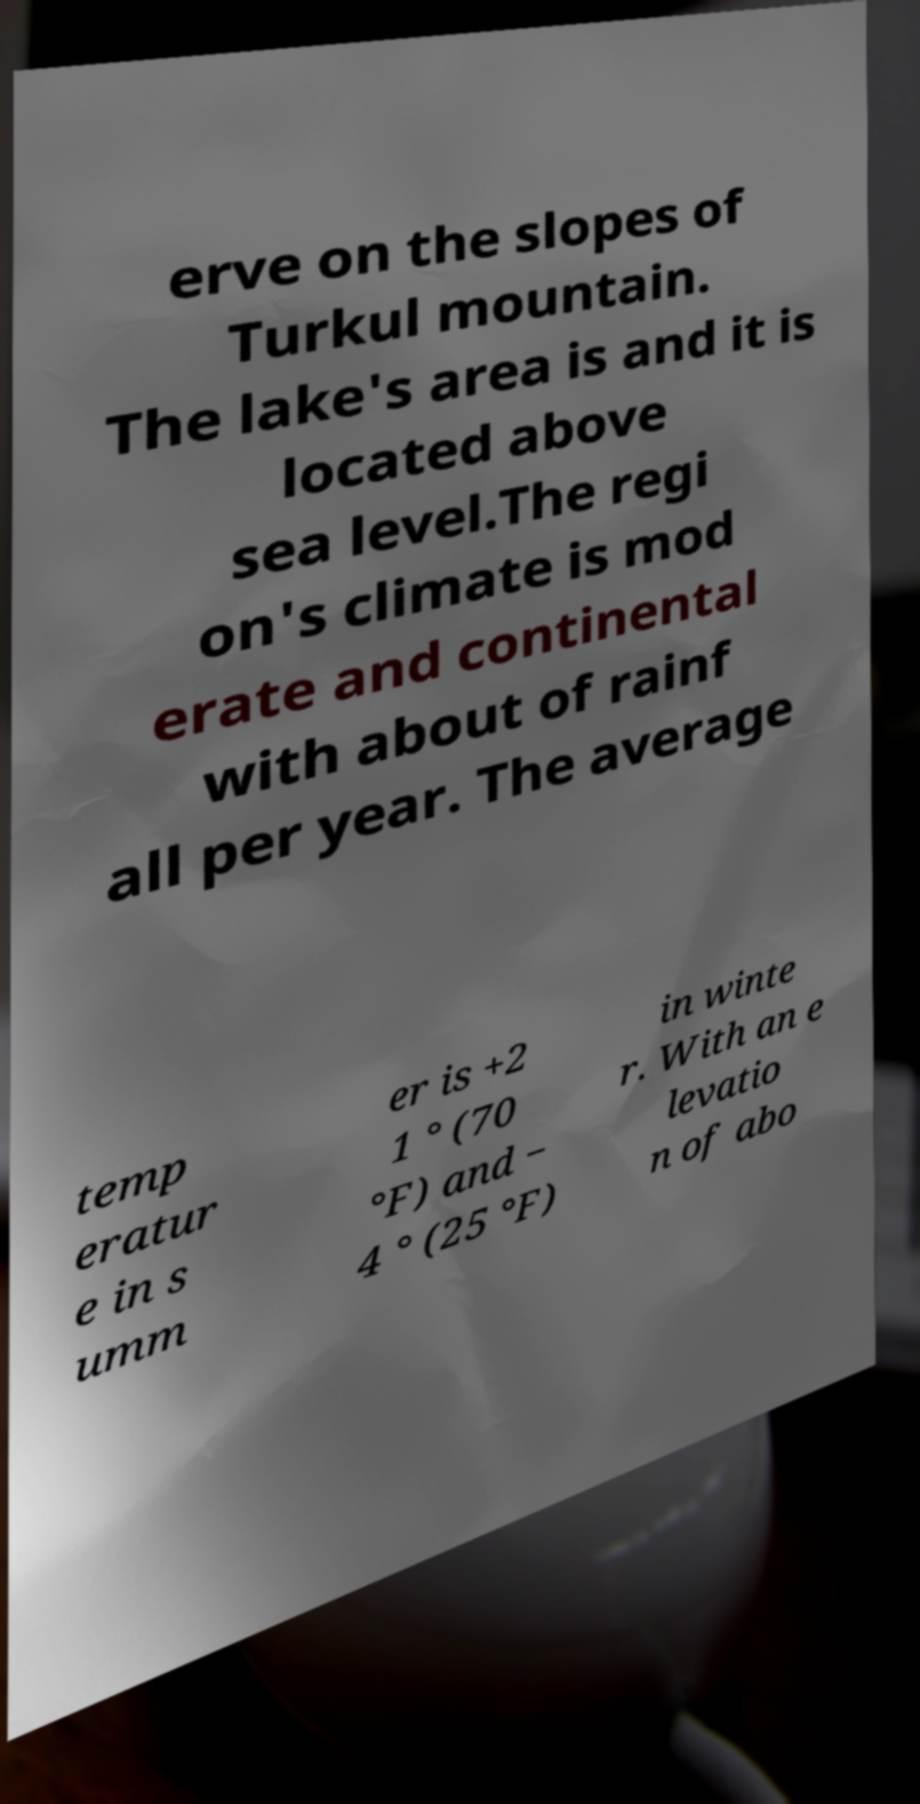I need the written content from this picture converted into text. Can you do that? erve on the slopes of Turkul mountain. The lake's area is and it is located above sea level.The regi on's climate is mod erate and continental with about of rainf all per year. The average temp eratur e in s umm er is +2 1 ° (70 °F) and − 4 ° (25 °F) in winte r. With an e levatio n of abo 